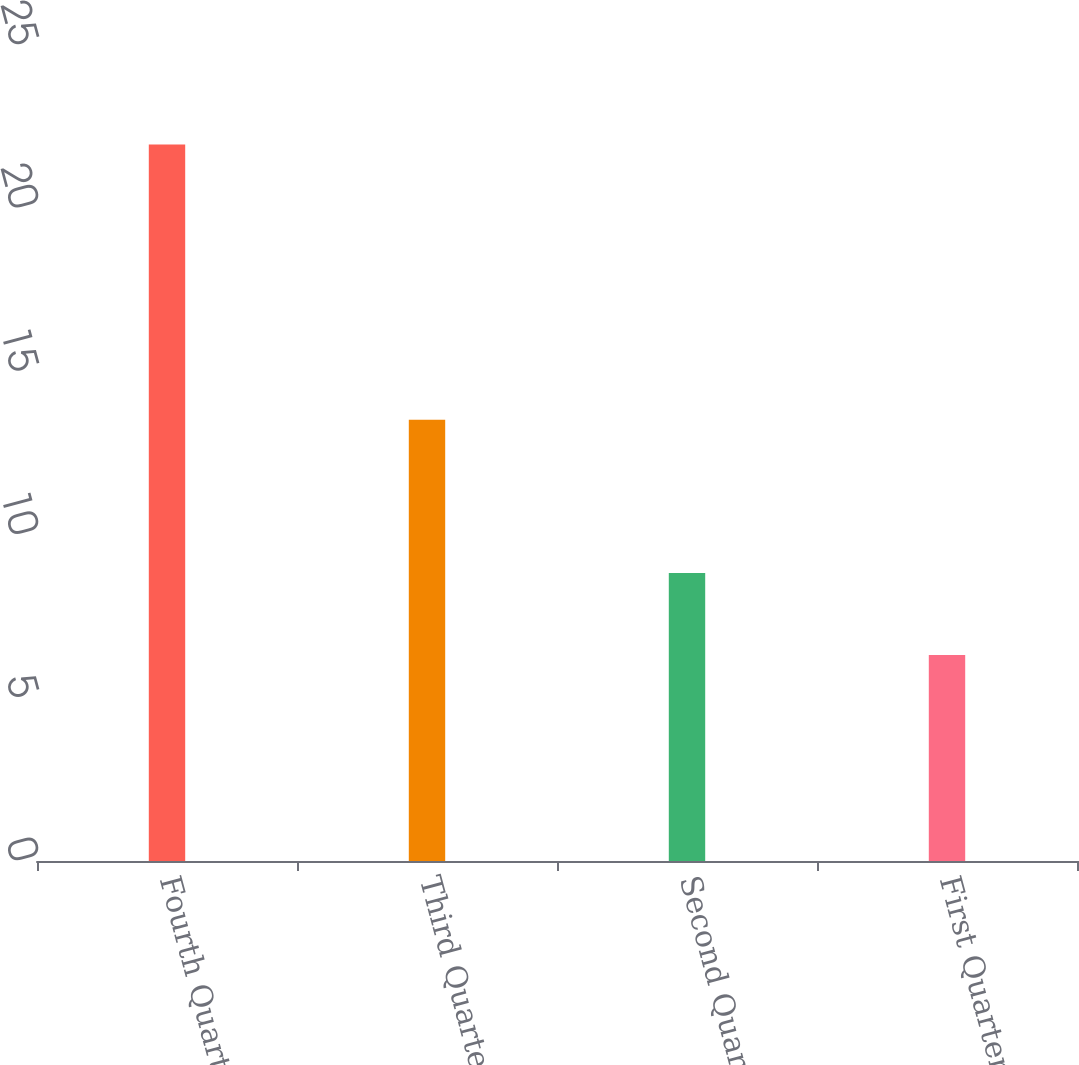Convert chart. <chart><loc_0><loc_0><loc_500><loc_500><bar_chart><fcel>Fourth Quarter<fcel>Third Quarter<fcel>Second Quarter<fcel>First Quarter<nl><fcel>21.95<fcel>13.52<fcel>8.82<fcel>6.31<nl></chart> 